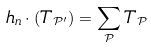<formula> <loc_0><loc_0><loc_500><loc_500>h _ { n } \cdot ( T _ { \mathcal { P ^ { \prime } } } ) = \sum _ { \mathcal { P } } T _ { \mathcal { P } }</formula> 